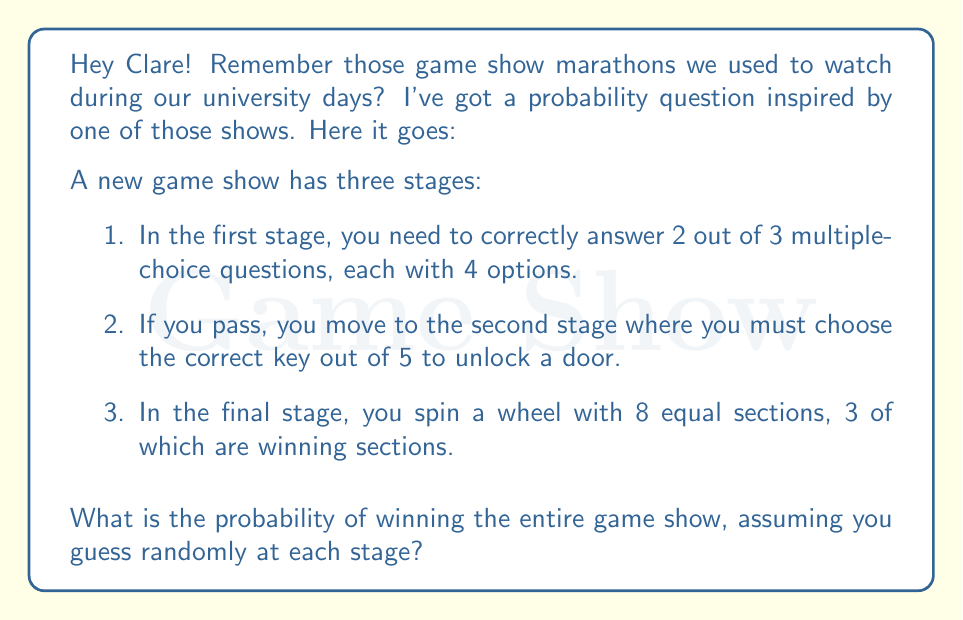Solve this math problem. Let's break this down step-by-step:

1) First stage: 
   - We need to calculate the probability of answering at least 2 out of 3 questions correctly.
   - For each question, the probability of a correct guess is $\frac{1}{4}$.
   - We can use the binomial probability formula:
     $$P(\text{at least 2 correct}) = P(2 \text{ correct}) + P(3 \text{ correct})$$
     $$= \binom{3}{2}(\frac{1}{4})^2(\frac{3}{4})^1 + \binom{3}{3}(\frac{1}{4})^3$$
     $$= 3 \cdot \frac{1}{16} \cdot \frac{3}{4} + \frac{1}{64} = \frac{9}{64} + \frac{1}{64} = \frac{10}{64} = \frac{5}{32}$$

2) Second stage:
   - We need to choose the correct key out of 5.
   - Probability = $\frac{1}{5}$

3) Third stage:
   - We need to land on one of the 3 winning sections out of 8 total sections.
   - Probability = $\frac{3}{8}$

4) To win the entire game, we need to succeed in all three stages.
   - The probability of this is the product of the individual probabilities:
     $$P(\text{winning}) = \frac{5}{32} \cdot \frac{1}{5} \cdot \frac{3}{8}$$

5) Simplifying:
   $$P(\text{winning}) = \frac{5}{32} \cdot \frac{1}{5} \cdot \frac{3}{8} = \frac{15}{1280} = \frac{3}{256}$$
Answer: $\frac{3}{256}$ 